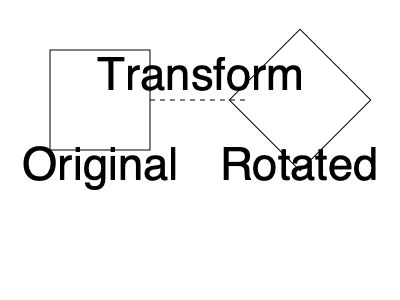Consider the spatial transformation shown in the diagram. How might this type of geometric manipulation contribute to a student's understanding of the concept of invariance in algebraic structures, and what cognitive processes are likely involved in making this connection? 1. Spatial Transformation: The diagram shows a square being rotated 45 degrees.

2. Invariance Concept: Despite the rotation, key properties of the square (side lengths, angles, area) remain unchanged. This illustrates geometric invariance.

3. Algebraic Structures: In abstract algebra, invariance refers to properties that remain constant under certain transformations. For example, the determinant of a matrix remains unchanged under certain operations.

4. Cognitive Processes:
   a) Visual-spatial processing: Recognizing the shape and its transformation.
   b) Abstract reasoning: Connecting the visual concept to abstract mathematical ideas.
   c) Analogical thinking: Mapping the geometric invariance to algebraic invariance.
   d) Mental rotation: Mentally manipulating the object to understand its properties.

5. Learning Connection:
   a) Students can visualize abstract concepts through concrete geometric examples.
   b) The spatial task reinforces the idea that some properties remain constant despite transformations.
   c) This visualization aids in understanding more complex mathematical structures where invariance is crucial (e.g., group theory, linear algebra).

6. Cognitive Impact:
   a) Enhances conceptual understanding by providing a concrete, visual anchor for abstract ideas.
   b) Develops mental flexibility in switching between visual and symbolic representations.
   c) Strengthens the ability to recognize patterns and structural similarities across different mathematical domains.

7. Mathematical Extension:
   Consider the transformation matrix $R = \begin{pmatrix} \cos \theta & -\sin \theta \\ \sin \theta & \cos \theta \end{pmatrix}$ for rotation by angle $\theta$. The property $\det(R) = 1$ illustrates algebraic invariance corresponding to the preserved area in the geometric case.
Answer: Spatial transformations enhance understanding of invariance by engaging visual-spatial processing, abstract reasoning, and analogical thinking, bridging concrete geometric concepts with abstract algebraic structures. 